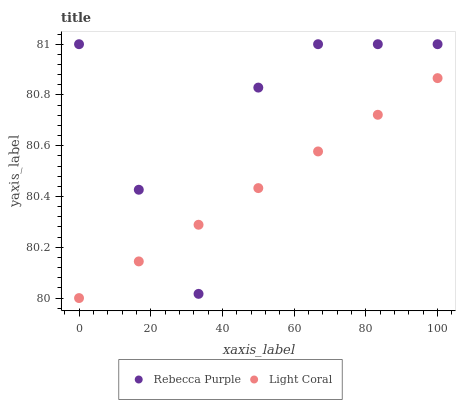Does Light Coral have the minimum area under the curve?
Answer yes or no. Yes. Does Rebecca Purple have the maximum area under the curve?
Answer yes or no. Yes. Does Rebecca Purple have the minimum area under the curve?
Answer yes or no. No. Is Light Coral the smoothest?
Answer yes or no. Yes. Is Rebecca Purple the roughest?
Answer yes or no. Yes. Is Rebecca Purple the smoothest?
Answer yes or no. No. Does Light Coral have the lowest value?
Answer yes or no. Yes. Does Rebecca Purple have the lowest value?
Answer yes or no. No. Does Rebecca Purple have the highest value?
Answer yes or no. Yes. Does Rebecca Purple intersect Light Coral?
Answer yes or no. Yes. Is Rebecca Purple less than Light Coral?
Answer yes or no. No. Is Rebecca Purple greater than Light Coral?
Answer yes or no. No. 